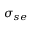<formula> <loc_0><loc_0><loc_500><loc_500>{ \sigma } _ { s e }</formula> 